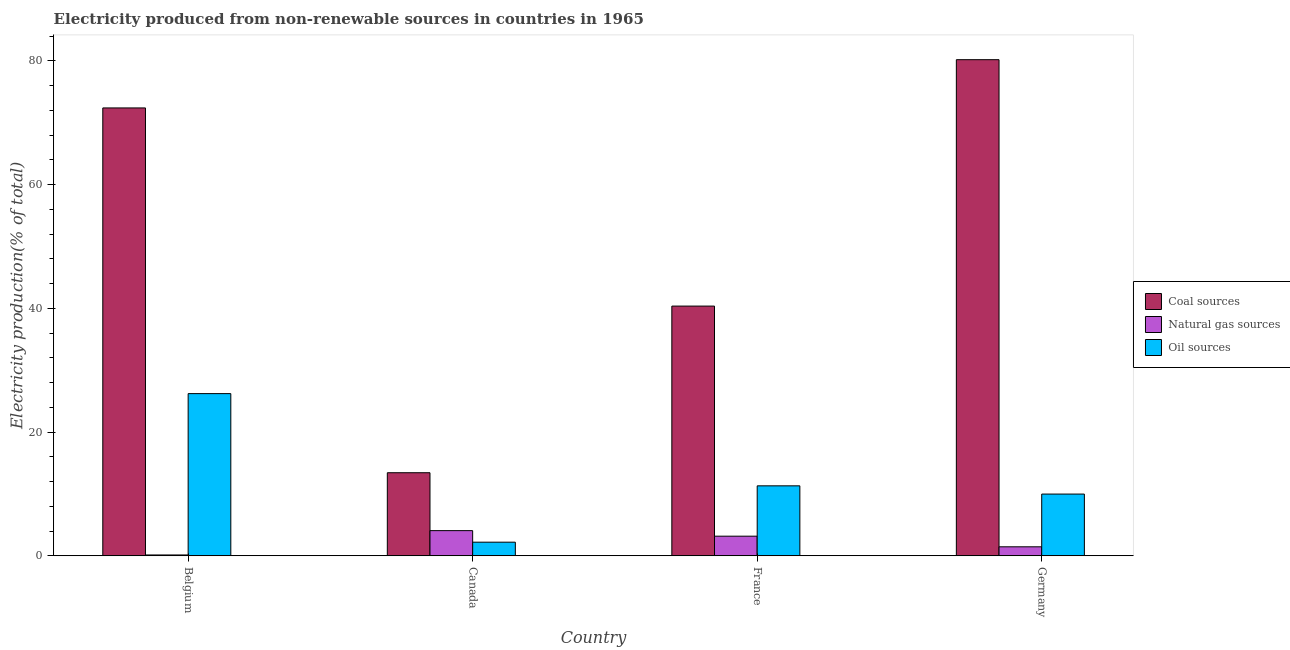Are the number of bars per tick equal to the number of legend labels?
Your response must be concise. Yes. Are the number of bars on each tick of the X-axis equal?
Offer a terse response. Yes. What is the percentage of electricity produced by oil sources in France?
Your answer should be very brief. 11.31. Across all countries, what is the maximum percentage of electricity produced by oil sources?
Ensure brevity in your answer.  26.21. Across all countries, what is the minimum percentage of electricity produced by oil sources?
Make the answer very short. 2.2. In which country was the percentage of electricity produced by natural gas maximum?
Ensure brevity in your answer.  Canada. In which country was the percentage of electricity produced by oil sources minimum?
Your answer should be very brief. Canada. What is the total percentage of electricity produced by natural gas in the graph?
Offer a very short reply. 8.82. What is the difference between the percentage of electricity produced by natural gas in Canada and that in Germany?
Offer a very short reply. 2.61. What is the difference between the percentage of electricity produced by coal in Canada and the percentage of electricity produced by oil sources in Germany?
Your answer should be compact. 3.45. What is the average percentage of electricity produced by oil sources per country?
Provide a succinct answer. 12.42. What is the difference between the percentage of electricity produced by oil sources and percentage of electricity produced by natural gas in Germany?
Give a very brief answer. 8.52. What is the ratio of the percentage of electricity produced by oil sources in Canada to that in France?
Make the answer very short. 0.19. Is the percentage of electricity produced by coal in Canada less than that in France?
Provide a succinct answer. Yes. What is the difference between the highest and the second highest percentage of electricity produced by coal?
Your answer should be compact. 7.8. What is the difference between the highest and the lowest percentage of electricity produced by oil sources?
Give a very brief answer. 24.01. Is the sum of the percentage of electricity produced by natural gas in Belgium and Germany greater than the maximum percentage of electricity produced by coal across all countries?
Offer a terse response. No. What does the 3rd bar from the left in Canada represents?
Your response must be concise. Oil sources. What does the 3rd bar from the right in Germany represents?
Provide a succinct answer. Coal sources. How many bars are there?
Offer a terse response. 12. What is the difference between two consecutive major ticks on the Y-axis?
Ensure brevity in your answer.  20. Does the graph contain any zero values?
Offer a terse response. No. Does the graph contain grids?
Offer a terse response. No. What is the title of the graph?
Ensure brevity in your answer.  Electricity produced from non-renewable sources in countries in 1965. Does "Wage workers" appear as one of the legend labels in the graph?
Offer a terse response. No. What is the Electricity production(% of total) of Coal sources in Belgium?
Offer a very short reply. 72.38. What is the Electricity production(% of total) in Natural gas sources in Belgium?
Provide a succinct answer. 0.14. What is the Electricity production(% of total) in Oil sources in Belgium?
Your response must be concise. 26.21. What is the Electricity production(% of total) in Coal sources in Canada?
Make the answer very short. 13.42. What is the Electricity production(% of total) in Natural gas sources in Canada?
Ensure brevity in your answer.  4.07. What is the Electricity production(% of total) of Oil sources in Canada?
Offer a very short reply. 2.2. What is the Electricity production(% of total) in Coal sources in France?
Provide a succinct answer. 40.36. What is the Electricity production(% of total) in Natural gas sources in France?
Ensure brevity in your answer.  3.17. What is the Electricity production(% of total) in Oil sources in France?
Ensure brevity in your answer.  11.31. What is the Electricity production(% of total) in Coal sources in Germany?
Make the answer very short. 80.18. What is the Electricity production(% of total) in Natural gas sources in Germany?
Make the answer very short. 1.45. What is the Electricity production(% of total) in Oil sources in Germany?
Offer a very short reply. 9.98. Across all countries, what is the maximum Electricity production(% of total) of Coal sources?
Give a very brief answer. 80.18. Across all countries, what is the maximum Electricity production(% of total) of Natural gas sources?
Offer a very short reply. 4.07. Across all countries, what is the maximum Electricity production(% of total) of Oil sources?
Provide a short and direct response. 26.21. Across all countries, what is the minimum Electricity production(% of total) of Coal sources?
Make the answer very short. 13.42. Across all countries, what is the minimum Electricity production(% of total) of Natural gas sources?
Ensure brevity in your answer.  0.14. Across all countries, what is the minimum Electricity production(% of total) in Oil sources?
Your response must be concise. 2.2. What is the total Electricity production(% of total) of Coal sources in the graph?
Offer a very short reply. 206.35. What is the total Electricity production(% of total) of Natural gas sources in the graph?
Make the answer very short. 8.82. What is the total Electricity production(% of total) in Oil sources in the graph?
Ensure brevity in your answer.  49.7. What is the difference between the Electricity production(% of total) of Coal sources in Belgium and that in Canada?
Offer a terse response. 58.96. What is the difference between the Electricity production(% of total) in Natural gas sources in Belgium and that in Canada?
Keep it short and to the point. -3.93. What is the difference between the Electricity production(% of total) of Oil sources in Belgium and that in Canada?
Provide a short and direct response. 24.01. What is the difference between the Electricity production(% of total) of Coal sources in Belgium and that in France?
Provide a succinct answer. 32.02. What is the difference between the Electricity production(% of total) of Natural gas sources in Belgium and that in France?
Your response must be concise. -3.03. What is the difference between the Electricity production(% of total) in Oil sources in Belgium and that in France?
Your response must be concise. 14.91. What is the difference between the Electricity production(% of total) of Coal sources in Belgium and that in Germany?
Provide a short and direct response. -7.8. What is the difference between the Electricity production(% of total) in Natural gas sources in Belgium and that in Germany?
Keep it short and to the point. -1.32. What is the difference between the Electricity production(% of total) of Oil sources in Belgium and that in Germany?
Your answer should be compact. 16.24. What is the difference between the Electricity production(% of total) of Coal sources in Canada and that in France?
Provide a short and direct response. -26.93. What is the difference between the Electricity production(% of total) of Natural gas sources in Canada and that in France?
Offer a very short reply. 0.9. What is the difference between the Electricity production(% of total) in Oil sources in Canada and that in France?
Your answer should be very brief. -9.11. What is the difference between the Electricity production(% of total) of Coal sources in Canada and that in Germany?
Your answer should be very brief. -66.76. What is the difference between the Electricity production(% of total) of Natural gas sources in Canada and that in Germany?
Your answer should be very brief. 2.61. What is the difference between the Electricity production(% of total) in Oil sources in Canada and that in Germany?
Your answer should be compact. -7.78. What is the difference between the Electricity production(% of total) in Coal sources in France and that in Germany?
Your response must be concise. -39.82. What is the difference between the Electricity production(% of total) in Natural gas sources in France and that in Germany?
Provide a short and direct response. 1.72. What is the difference between the Electricity production(% of total) in Oil sources in France and that in Germany?
Offer a very short reply. 1.33. What is the difference between the Electricity production(% of total) of Coal sources in Belgium and the Electricity production(% of total) of Natural gas sources in Canada?
Your response must be concise. 68.32. What is the difference between the Electricity production(% of total) in Coal sources in Belgium and the Electricity production(% of total) in Oil sources in Canada?
Your answer should be compact. 70.18. What is the difference between the Electricity production(% of total) in Natural gas sources in Belgium and the Electricity production(% of total) in Oil sources in Canada?
Your response must be concise. -2.07. What is the difference between the Electricity production(% of total) of Coal sources in Belgium and the Electricity production(% of total) of Natural gas sources in France?
Your response must be concise. 69.21. What is the difference between the Electricity production(% of total) in Coal sources in Belgium and the Electricity production(% of total) in Oil sources in France?
Provide a short and direct response. 61.08. What is the difference between the Electricity production(% of total) in Natural gas sources in Belgium and the Electricity production(% of total) in Oil sources in France?
Your answer should be compact. -11.17. What is the difference between the Electricity production(% of total) of Coal sources in Belgium and the Electricity production(% of total) of Natural gas sources in Germany?
Offer a very short reply. 70.93. What is the difference between the Electricity production(% of total) in Coal sources in Belgium and the Electricity production(% of total) in Oil sources in Germany?
Provide a succinct answer. 62.41. What is the difference between the Electricity production(% of total) in Natural gas sources in Belgium and the Electricity production(% of total) in Oil sources in Germany?
Offer a very short reply. -9.84. What is the difference between the Electricity production(% of total) of Coal sources in Canada and the Electricity production(% of total) of Natural gas sources in France?
Provide a succinct answer. 10.25. What is the difference between the Electricity production(% of total) of Coal sources in Canada and the Electricity production(% of total) of Oil sources in France?
Provide a short and direct response. 2.12. What is the difference between the Electricity production(% of total) of Natural gas sources in Canada and the Electricity production(% of total) of Oil sources in France?
Offer a terse response. -7.24. What is the difference between the Electricity production(% of total) of Coal sources in Canada and the Electricity production(% of total) of Natural gas sources in Germany?
Your answer should be very brief. 11.97. What is the difference between the Electricity production(% of total) of Coal sources in Canada and the Electricity production(% of total) of Oil sources in Germany?
Offer a terse response. 3.45. What is the difference between the Electricity production(% of total) in Natural gas sources in Canada and the Electricity production(% of total) in Oil sources in Germany?
Give a very brief answer. -5.91. What is the difference between the Electricity production(% of total) of Coal sources in France and the Electricity production(% of total) of Natural gas sources in Germany?
Keep it short and to the point. 38.91. What is the difference between the Electricity production(% of total) in Coal sources in France and the Electricity production(% of total) in Oil sources in Germany?
Your answer should be compact. 30.38. What is the difference between the Electricity production(% of total) of Natural gas sources in France and the Electricity production(% of total) of Oil sources in Germany?
Your answer should be very brief. -6.81. What is the average Electricity production(% of total) in Coal sources per country?
Provide a short and direct response. 51.59. What is the average Electricity production(% of total) in Natural gas sources per country?
Offer a terse response. 2.21. What is the average Electricity production(% of total) of Oil sources per country?
Your response must be concise. 12.42. What is the difference between the Electricity production(% of total) in Coal sources and Electricity production(% of total) in Natural gas sources in Belgium?
Give a very brief answer. 72.25. What is the difference between the Electricity production(% of total) in Coal sources and Electricity production(% of total) in Oil sources in Belgium?
Provide a short and direct response. 46.17. What is the difference between the Electricity production(% of total) of Natural gas sources and Electricity production(% of total) of Oil sources in Belgium?
Offer a very short reply. -26.08. What is the difference between the Electricity production(% of total) in Coal sources and Electricity production(% of total) in Natural gas sources in Canada?
Offer a very short reply. 9.36. What is the difference between the Electricity production(% of total) of Coal sources and Electricity production(% of total) of Oil sources in Canada?
Provide a succinct answer. 11.22. What is the difference between the Electricity production(% of total) of Natural gas sources and Electricity production(% of total) of Oil sources in Canada?
Keep it short and to the point. 1.86. What is the difference between the Electricity production(% of total) in Coal sources and Electricity production(% of total) in Natural gas sources in France?
Offer a very short reply. 37.19. What is the difference between the Electricity production(% of total) in Coal sources and Electricity production(% of total) in Oil sources in France?
Your answer should be compact. 29.05. What is the difference between the Electricity production(% of total) in Natural gas sources and Electricity production(% of total) in Oil sources in France?
Provide a short and direct response. -8.14. What is the difference between the Electricity production(% of total) of Coal sources and Electricity production(% of total) of Natural gas sources in Germany?
Provide a short and direct response. 78.73. What is the difference between the Electricity production(% of total) in Coal sources and Electricity production(% of total) in Oil sources in Germany?
Your response must be concise. 70.21. What is the difference between the Electricity production(% of total) of Natural gas sources and Electricity production(% of total) of Oil sources in Germany?
Your response must be concise. -8.52. What is the ratio of the Electricity production(% of total) of Coal sources in Belgium to that in Canada?
Ensure brevity in your answer.  5.39. What is the ratio of the Electricity production(% of total) of Oil sources in Belgium to that in Canada?
Keep it short and to the point. 11.91. What is the ratio of the Electricity production(% of total) in Coal sources in Belgium to that in France?
Provide a succinct answer. 1.79. What is the ratio of the Electricity production(% of total) of Natural gas sources in Belgium to that in France?
Your answer should be very brief. 0.04. What is the ratio of the Electricity production(% of total) in Oil sources in Belgium to that in France?
Make the answer very short. 2.32. What is the ratio of the Electricity production(% of total) of Coal sources in Belgium to that in Germany?
Your answer should be very brief. 0.9. What is the ratio of the Electricity production(% of total) of Natural gas sources in Belgium to that in Germany?
Give a very brief answer. 0.09. What is the ratio of the Electricity production(% of total) in Oil sources in Belgium to that in Germany?
Provide a short and direct response. 2.63. What is the ratio of the Electricity production(% of total) of Coal sources in Canada to that in France?
Give a very brief answer. 0.33. What is the ratio of the Electricity production(% of total) in Natural gas sources in Canada to that in France?
Provide a succinct answer. 1.28. What is the ratio of the Electricity production(% of total) of Oil sources in Canada to that in France?
Your response must be concise. 0.19. What is the ratio of the Electricity production(% of total) of Coal sources in Canada to that in Germany?
Offer a very short reply. 0.17. What is the ratio of the Electricity production(% of total) of Natural gas sources in Canada to that in Germany?
Ensure brevity in your answer.  2.8. What is the ratio of the Electricity production(% of total) of Oil sources in Canada to that in Germany?
Make the answer very short. 0.22. What is the ratio of the Electricity production(% of total) of Coal sources in France to that in Germany?
Offer a terse response. 0.5. What is the ratio of the Electricity production(% of total) of Natural gas sources in France to that in Germany?
Make the answer very short. 2.18. What is the ratio of the Electricity production(% of total) in Oil sources in France to that in Germany?
Provide a short and direct response. 1.13. What is the difference between the highest and the second highest Electricity production(% of total) in Coal sources?
Ensure brevity in your answer.  7.8. What is the difference between the highest and the second highest Electricity production(% of total) of Natural gas sources?
Make the answer very short. 0.9. What is the difference between the highest and the second highest Electricity production(% of total) of Oil sources?
Your response must be concise. 14.91. What is the difference between the highest and the lowest Electricity production(% of total) of Coal sources?
Offer a very short reply. 66.76. What is the difference between the highest and the lowest Electricity production(% of total) of Natural gas sources?
Provide a short and direct response. 3.93. What is the difference between the highest and the lowest Electricity production(% of total) of Oil sources?
Your answer should be very brief. 24.01. 